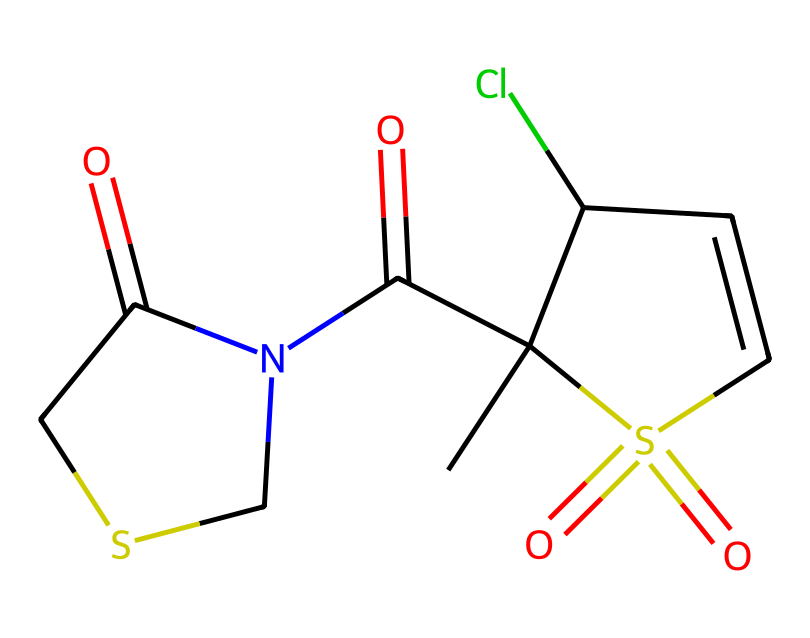What is the molecular formula of captan? By interpreting the SMILES representation, we can count the various atoms present in the structure: there are 9 carbon atoms (C), 10 hydrogen atoms (H), 1 nitrogen atom (N), 1 sulfur atom (S), 2 oxygen atoms (O), and 1 chlorine atom (Cl). Therefore, the molecular formula is C9H10ClN2O3S.
Answer: C9H10ClN2O3S How many rings are present in the structure of captan? Upon analyzing the SMILES formula, we notice that "C1" and "CC1" indicate a cyclic structure, meaning captan has one ring in its molecular structure that includes multiple atoms.
Answer: 1 What functional groups are present in captan? Looking at the structure, we identify the following functional groups: a sulfonamide (due to the presence of S(=O)(=O)), a carbonyl (C=O), and a chlorine atom (Cl) attached to the cyclic structure. These indicate the presence of multiple functional groups.
Answer: sulfonamide, carbonyl, chlorine What is the role of sulfur in captan's structure? Analyzing the structure, the sulfur atom is part of the sulfonamide group, which is essential for the fungicidal properties of captan, enhancing its activity against fungi.
Answer: fungicide activity What bond types are primarily found in captan? The bonds present in captan's structure include single bonds (between most carbon and hydrogen atoms), double bonds (notably in the carbonyl group), and a sulfonyl bond (S=O). The diverse bonding contributes to the molecule's stability and reactivity.
Answer: single and double bonds 